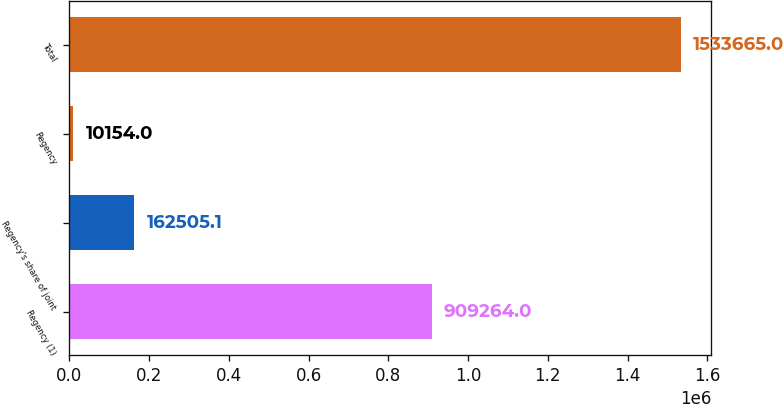Convert chart. <chart><loc_0><loc_0><loc_500><loc_500><bar_chart><fcel>Regency (1)<fcel>Regency's share of joint<fcel>Regency<fcel>Total<nl><fcel>909264<fcel>162505<fcel>10154<fcel>1.53366e+06<nl></chart> 